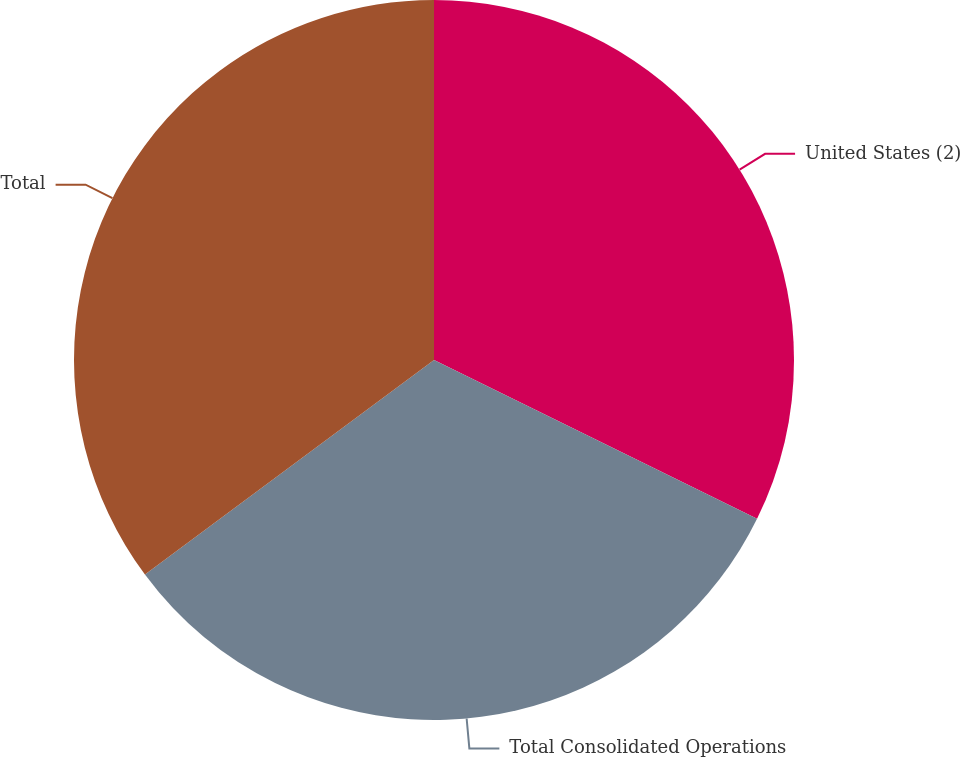<chart> <loc_0><loc_0><loc_500><loc_500><pie_chart><fcel>United States (2)<fcel>Total Consolidated Operations<fcel>Total<nl><fcel>32.27%<fcel>32.56%<fcel>35.16%<nl></chart> 